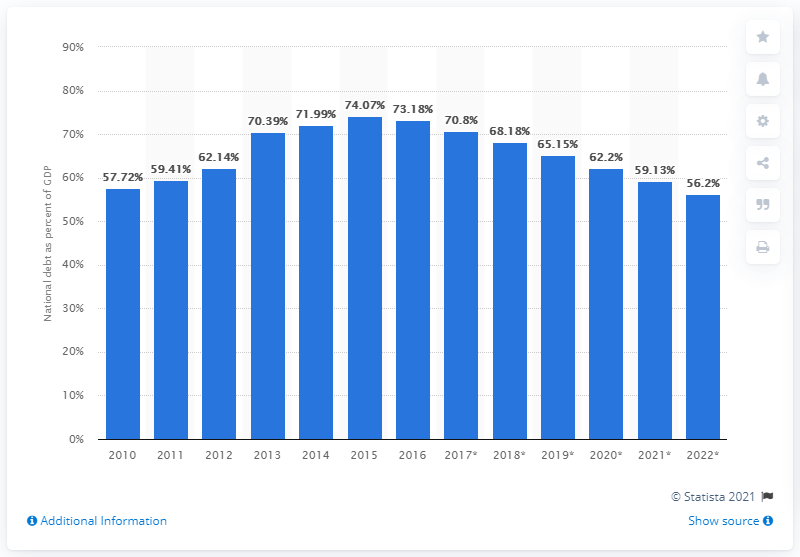Highlight a few significant elements in this photo. In 2016, the national debt of Albania was 73.18. 